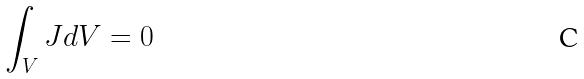Convert formula to latex. <formula><loc_0><loc_0><loc_500><loc_500>\int _ { V } J d V = 0</formula> 